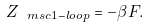Convert formula to latex. <formula><loc_0><loc_0><loc_500><loc_500>Z _ { \ m s c { 1 - l o o p } } = - \beta F .</formula> 